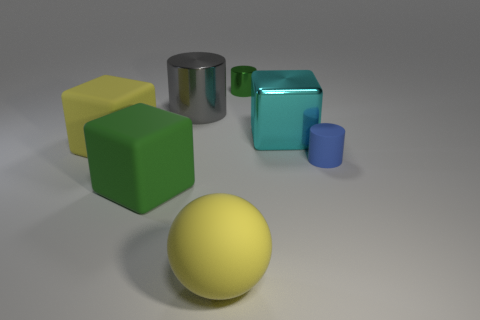Add 3 green objects. How many objects exist? 10 Subtract all cubes. How many objects are left? 4 Subtract all yellow balls. Subtract all tiny things. How many objects are left? 4 Add 3 large matte objects. How many large matte objects are left? 6 Add 1 large green matte things. How many large green matte things exist? 2 Subtract 1 yellow cubes. How many objects are left? 6 